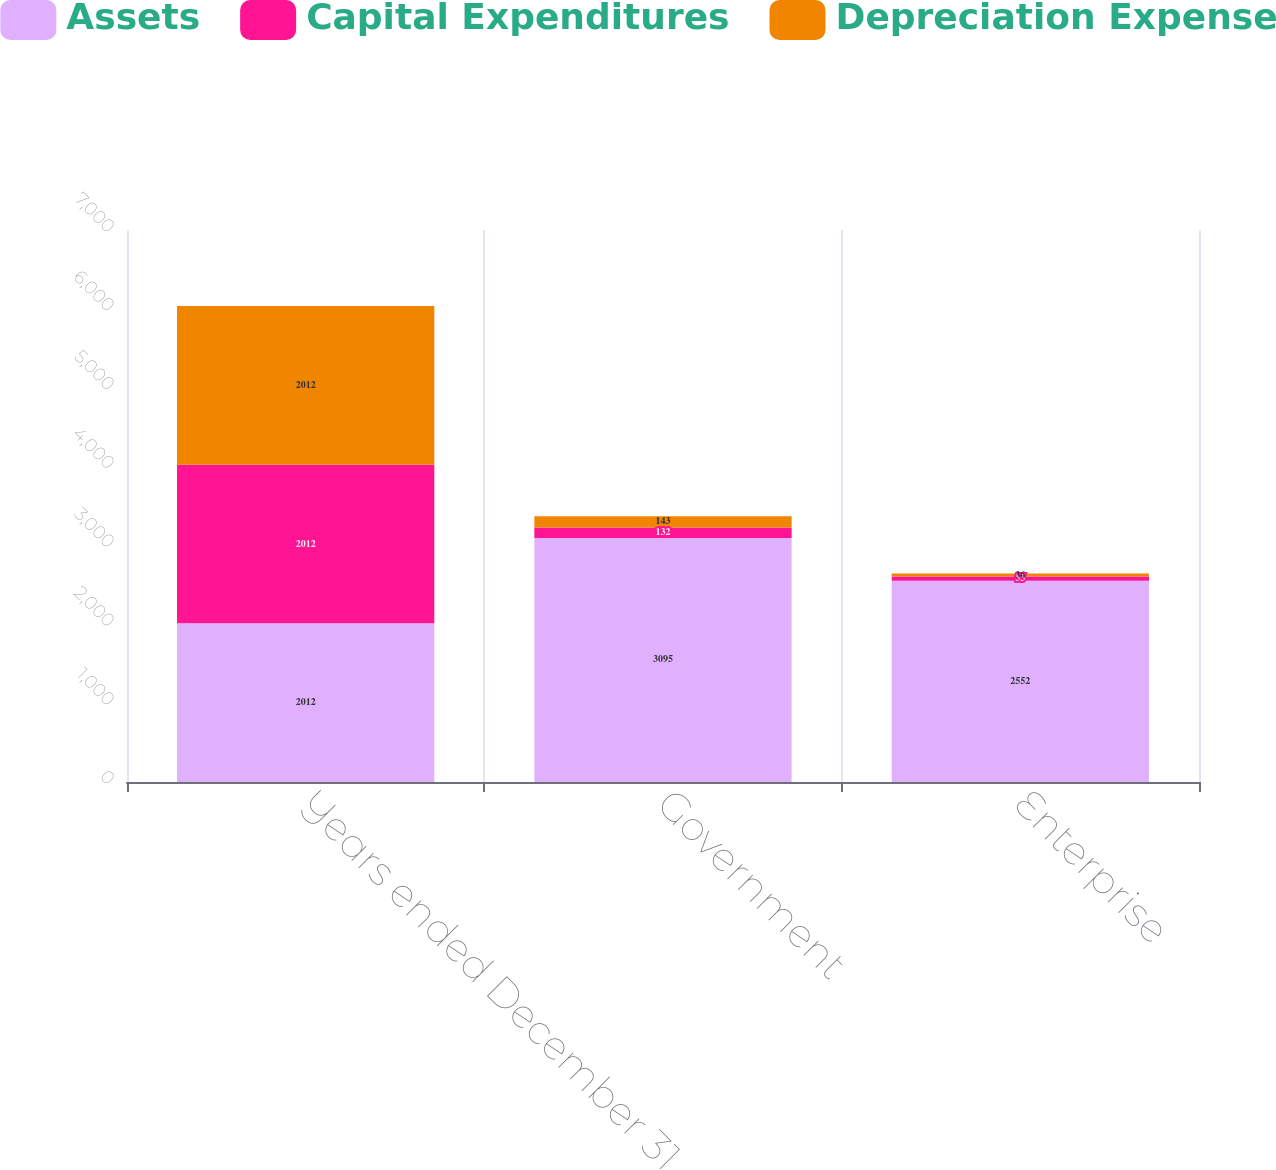Convert chart. <chart><loc_0><loc_0><loc_500><loc_500><stacked_bar_chart><ecel><fcel>Years ended December 31<fcel>Government<fcel>Enterprise<nl><fcel>Assets<fcel>2012<fcel>3095<fcel>2552<nl><fcel>Capital Expenditures<fcel>2012<fcel>132<fcel>55<nl><fcel>Depreciation Expense<fcel>2012<fcel>143<fcel>36<nl></chart> 